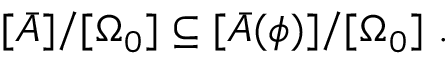<formula> <loc_0><loc_0><loc_500><loc_500>[ \bar { A } ] / [ \Omega _ { 0 } ] \subseteq [ \bar { A } ( \phi ) ] / [ \Omega _ { 0 } ] \ .</formula> 